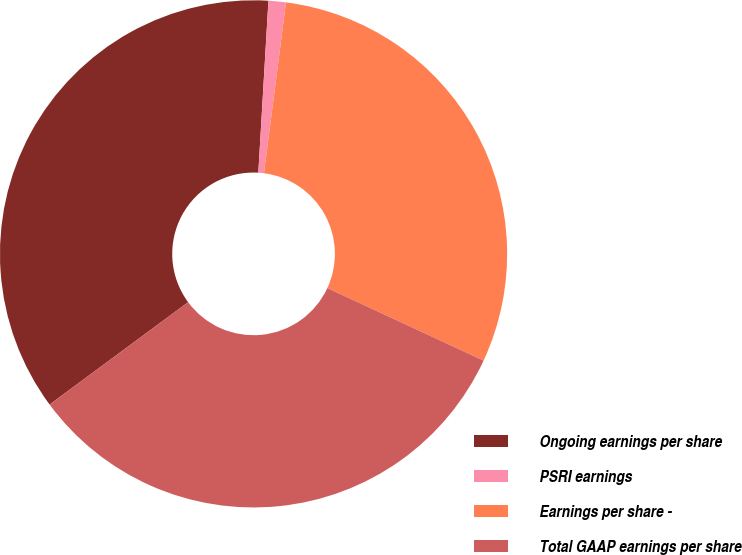Convert chart to OTSL. <chart><loc_0><loc_0><loc_500><loc_500><pie_chart><fcel>Ongoing earnings per share<fcel>PSRI earnings<fcel>Earnings per share -<fcel>Total GAAP earnings per share<nl><fcel>36.06%<fcel>1.11%<fcel>29.87%<fcel>32.96%<nl></chart> 